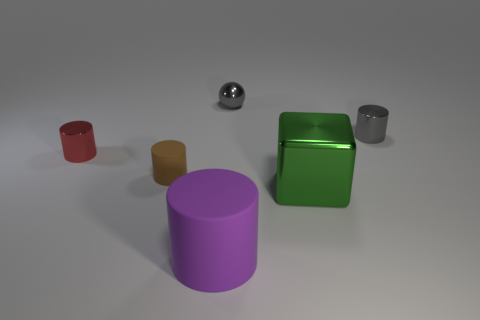There is a metallic cylinder on the right side of the brown cylinder; is its color the same as the metallic sphere?
Keep it short and to the point. Yes. There is a sphere; is its color the same as the metal cylinder that is behind the small red cylinder?
Your answer should be compact. Yes. Are there any small red objects that have the same material as the small brown object?
Provide a succinct answer. No. What is the material of the purple thing?
Give a very brief answer. Rubber. What shape is the matte thing behind the large thing that is behind the rubber cylinder to the right of the brown rubber thing?
Offer a terse response. Cylinder. Are there more big matte cylinders that are to the left of the sphere than tiny purple things?
Ensure brevity in your answer.  Yes. There is a brown thing; is it the same shape as the big metallic object that is on the right side of the purple matte cylinder?
Provide a short and direct response. No. There is a gray object that is behind the tiny metal cylinder that is to the right of the shiny sphere; what number of green shiny objects are to the right of it?
Provide a succinct answer. 1. What color is the matte object that is the same size as the green metal block?
Make the answer very short. Purple. How big is the matte object that is behind the cylinder that is in front of the small brown thing?
Provide a succinct answer. Small. 